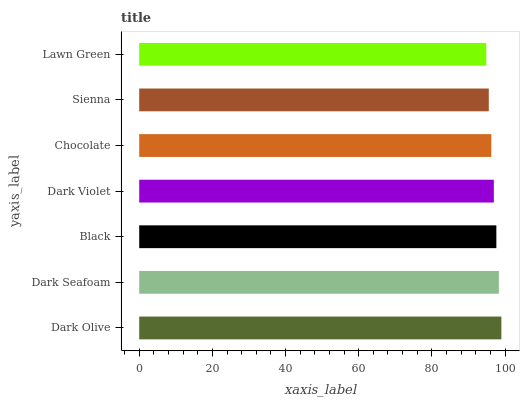Is Lawn Green the minimum?
Answer yes or no. Yes. Is Dark Olive the maximum?
Answer yes or no. Yes. Is Dark Seafoam the minimum?
Answer yes or no. No. Is Dark Seafoam the maximum?
Answer yes or no. No. Is Dark Olive greater than Dark Seafoam?
Answer yes or no. Yes. Is Dark Seafoam less than Dark Olive?
Answer yes or no. Yes. Is Dark Seafoam greater than Dark Olive?
Answer yes or no. No. Is Dark Olive less than Dark Seafoam?
Answer yes or no. No. Is Dark Violet the high median?
Answer yes or no. Yes. Is Dark Violet the low median?
Answer yes or no. Yes. Is Dark Olive the high median?
Answer yes or no. No. Is Lawn Green the low median?
Answer yes or no. No. 